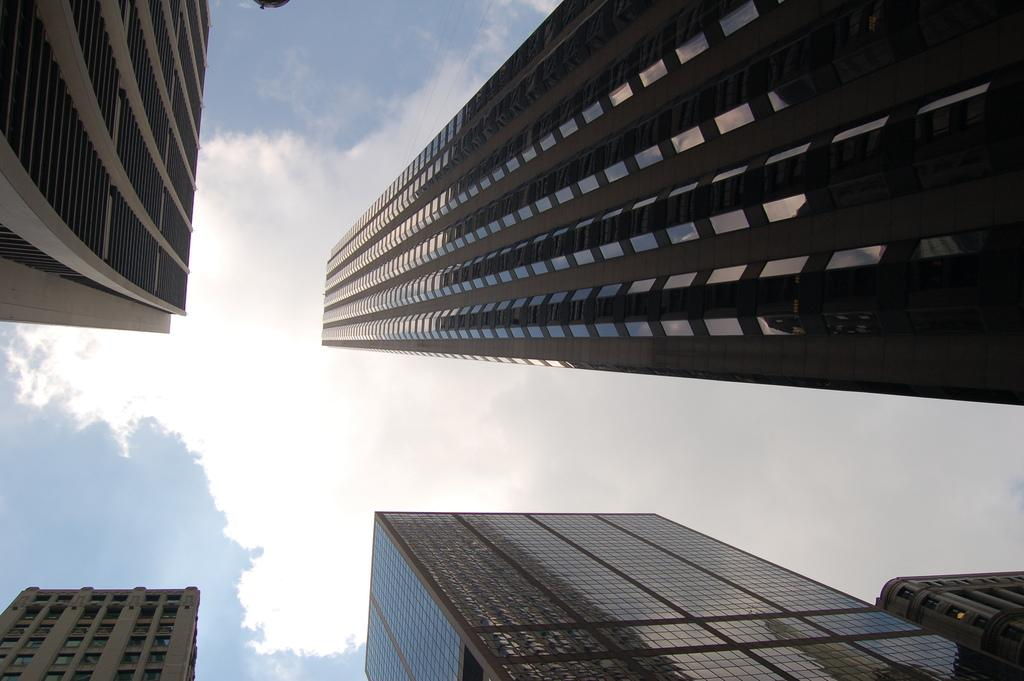What type of structures can be seen in the image? There are buildings in the image. What is visible in the background of the image? The sky is visible in the background of the image. What can be observed in the sky? There are clouds in the sky. What type of credit can be seen on the buildings in the image? There is no credit visible on the buildings in the image. How does the heat affect the buildings in the image? The provided facts do not mention any heat or its effects on the buildings. 